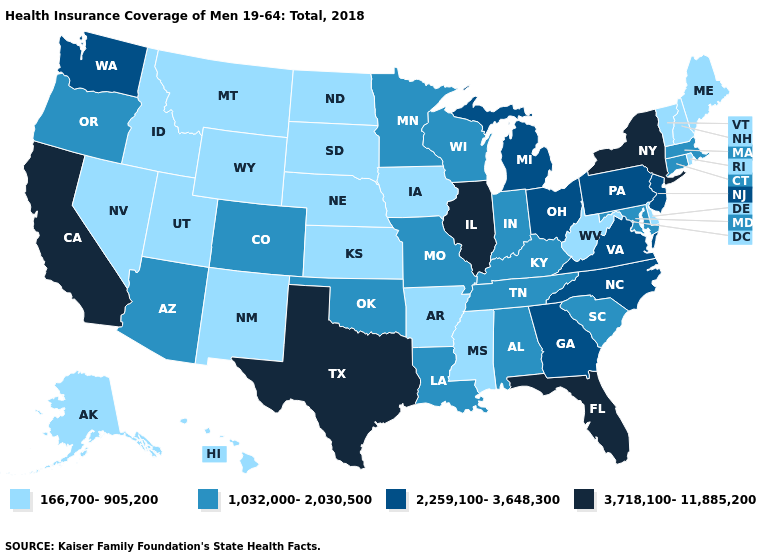What is the value of West Virginia?
Give a very brief answer. 166,700-905,200. Does North Carolina have the same value as Washington?
Quick response, please. Yes. Does Massachusetts have the highest value in the Northeast?
Be succinct. No. Does Washington have a higher value than Texas?
Answer briefly. No. Does Oregon have a higher value than Minnesota?
Concise answer only. No. Name the states that have a value in the range 166,700-905,200?
Concise answer only. Alaska, Arkansas, Delaware, Hawaii, Idaho, Iowa, Kansas, Maine, Mississippi, Montana, Nebraska, Nevada, New Hampshire, New Mexico, North Dakota, Rhode Island, South Dakota, Utah, Vermont, West Virginia, Wyoming. Name the states that have a value in the range 3,718,100-11,885,200?
Concise answer only. California, Florida, Illinois, New York, Texas. Which states have the lowest value in the USA?
Keep it brief. Alaska, Arkansas, Delaware, Hawaii, Idaho, Iowa, Kansas, Maine, Mississippi, Montana, Nebraska, Nevada, New Hampshire, New Mexico, North Dakota, Rhode Island, South Dakota, Utah, Vermont, West Virginia, Wyoming. What is the highest value in states that border Minnesota?
Quick response, please. 1,032,000-2,030,500. Is the legend a continuous bar?
Keep it brief. No. Among the states that border Arkansas , which have the lowest value?
Write a very short answer. Mississippi. What is the value of Montana?
Keep it brief. 166,700-905,200. Name the states that have a value in the range 3,718,100-11,885,200?
Give a very brief answer. California, Florida, Illinois, New York, Texas. Which states hav the highest value in the Northeast?
Be succinct. New York. 